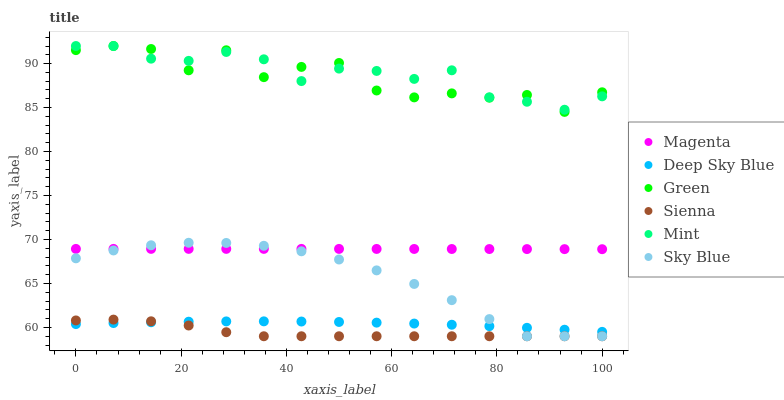Does Sienna have the minimum area under the curve?
Answer yes or no. Yes. Does Mint have the maximum area under the curve?
Answer yes or no. Yes. Does Green have the minimum area under the curve?
Answer yes or no. No. Does Green have the maximum area under the curve?
Answer yes or no. No. Is Magenta the smoothest?
Answer yes or no. Yes. Is Green the roughest?
Answer yes or no. Yes. Is Deep Sky Blue the smoothest?
Answer yes or no. No. Is Deep Sky Blue the roughest?
Answer yes or no. No. Does Sienna have the lowest value?
Answer yes or no. Yes. Does Green have the lowest value?
Answer yes or no. No. Does Mint have the highest value?
Answer yes or no. Yes. Does Deep Sky Blue have the highest value?
Answer yes or no. No. Is Deep Sky Blue less than Mint?
Answer yes or no. Yes. Is Mint greater than Sky Blue?
Answer yes or no. Yes. Does Sienna intersect Deep Sky Blue?
Answer yes or no. Yes. Is Sienna less than Deep Sky Blue?
Answer yes or no. No. Is Sienna greater than Deep Sky Blue?
Answer yes or no. No. Does Deep Sky Blue intersect Mint?
Answer yes or no. No. 